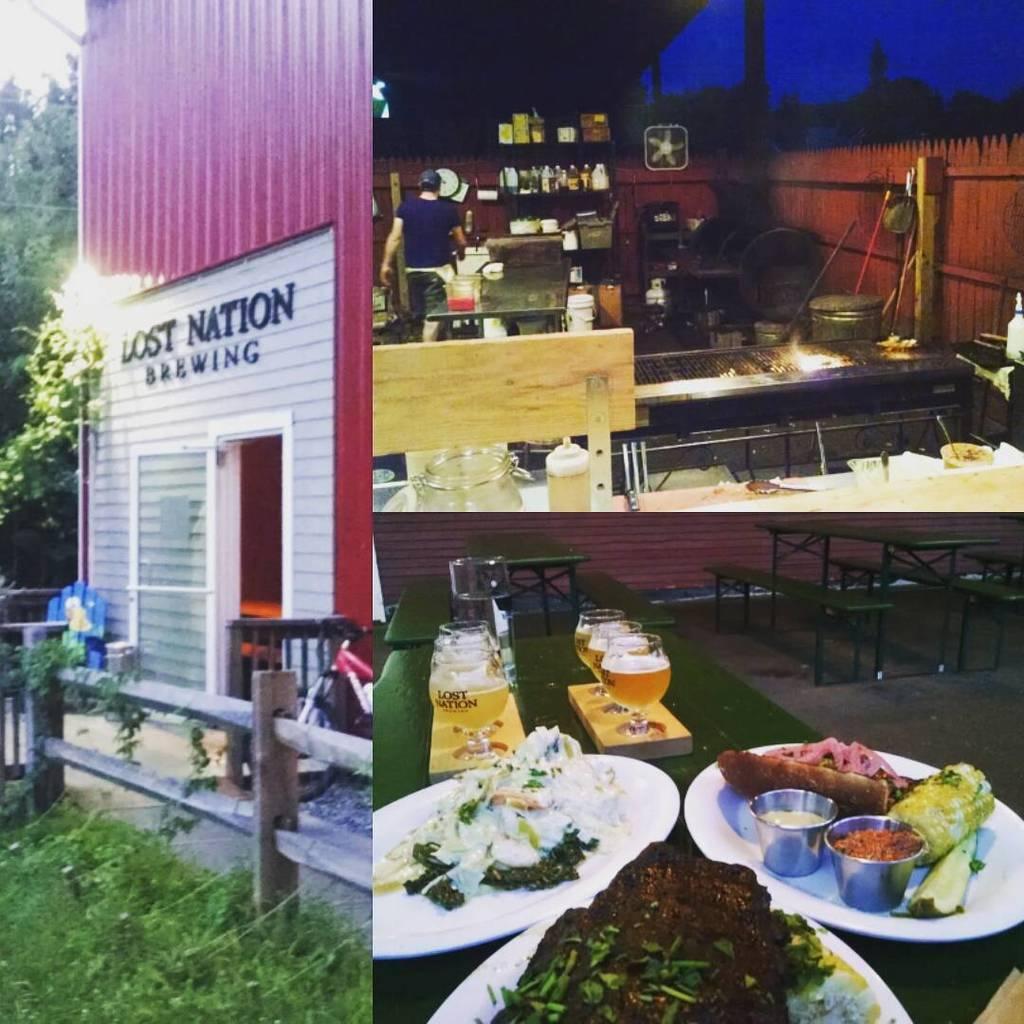How would you summarize this image in a sentence or two? In the picture we can see two images, in first image we can see a house with a glass door and besides, we can see a railing and a grass to the path and in the background, we can see trees and a light in the house, in the second image inside the house we can see some table with some eatable items and racks and a person standing near it. 